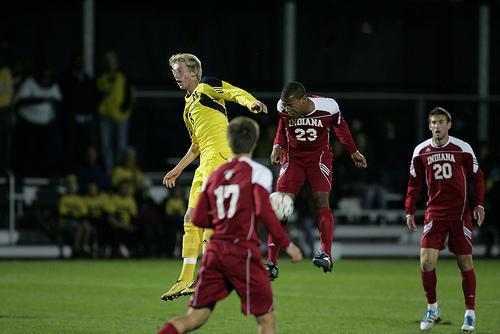How many men are wearing a yellow uniform?
Give a very brief answer. 1. 